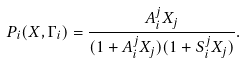<formula> <loc_0><loc_0><loc_500><loc_500>P _ { i } ( { X } , { \Gamma } _ { i } ) = \frac { A ^ { j } _ { i } X _ { j } } { ( 1 + A ^ { j } _ { i } X _ { j } ) ( 1 + S ^ { j } _ { i } X _ { j } ) } .</formula> 